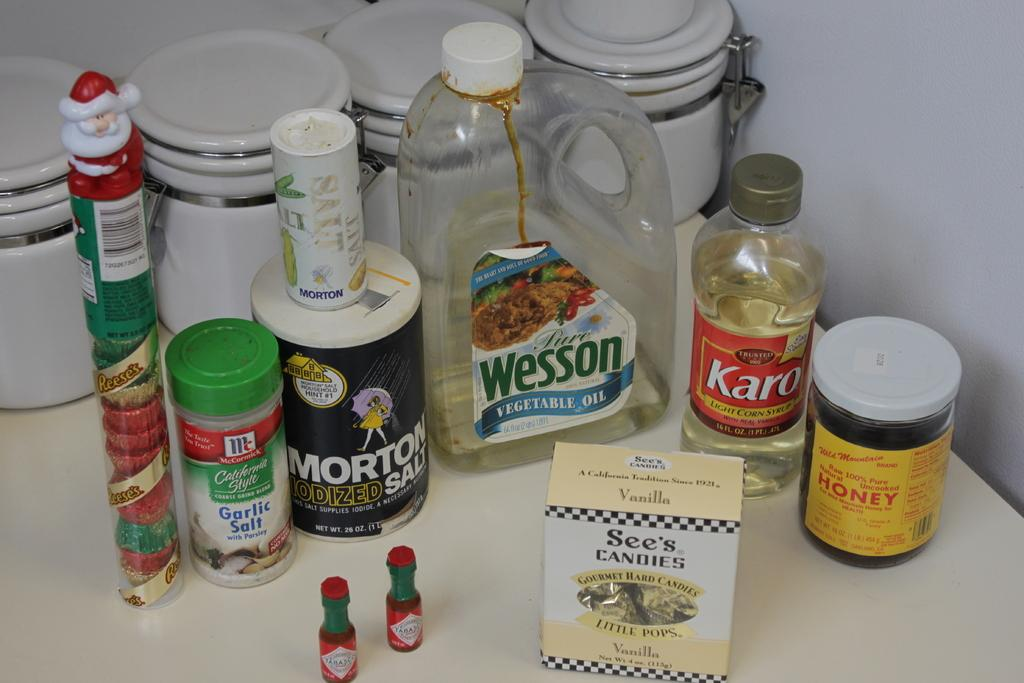What type of objects can be seen on the table in the image? There are bottles, containers, and a box on the table in the image. What is the color of the table in the image? The table is white. What can be seen in the background of the image? There is a wall in the background of the image. What type of net is hanging on the wall in the image? There is no net present on the wall in the image. 